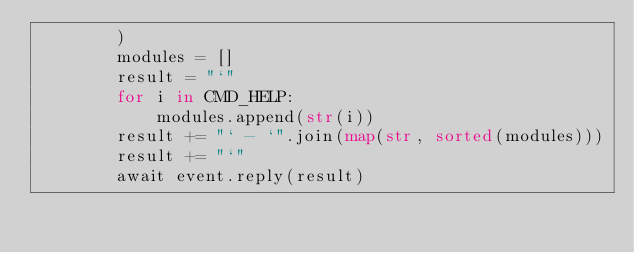Convert code to text. <code><loc_0><loc_0><loc_500><loc_500><_Python_>        )
        modules = []
        result = "`"
        for i in CMD_HELP:
            modules.append(str(i))
        result += "` - `".join(map(str, sorted(modules)))
        result += "`"
        await event.reply(result)
</code> 